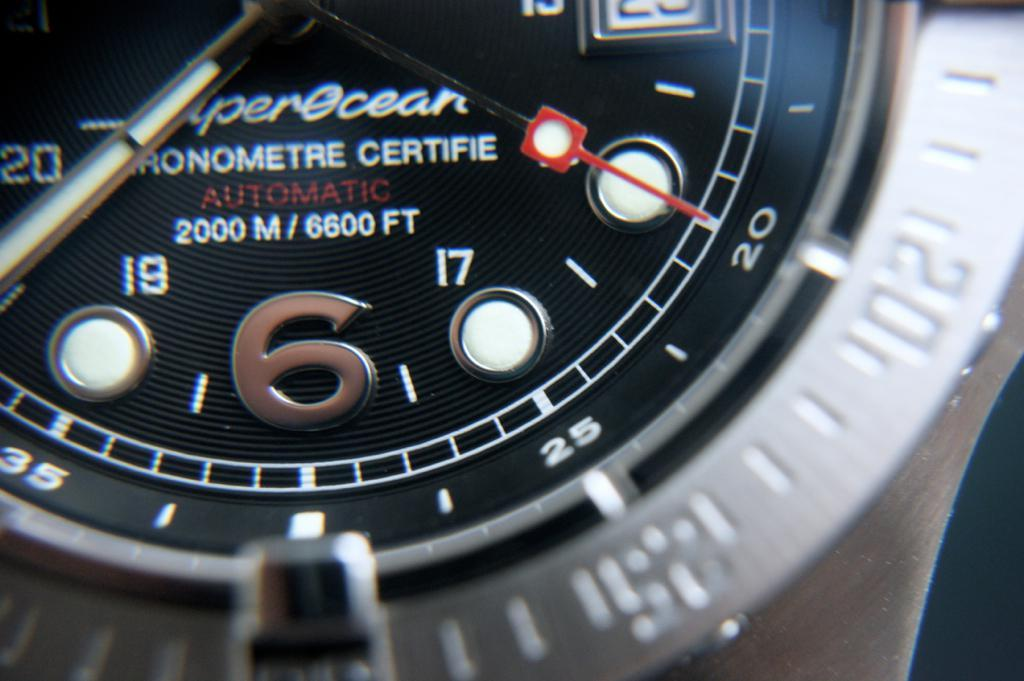Provide a one-sentence caption for the provided image. A close up picture of a watch that reads AUTOMATIC 2000 M / 6600 FT. 